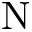Convert formula to latex. <formula><loc_0><loc_0><loc_500><loc_500>N</formula> 